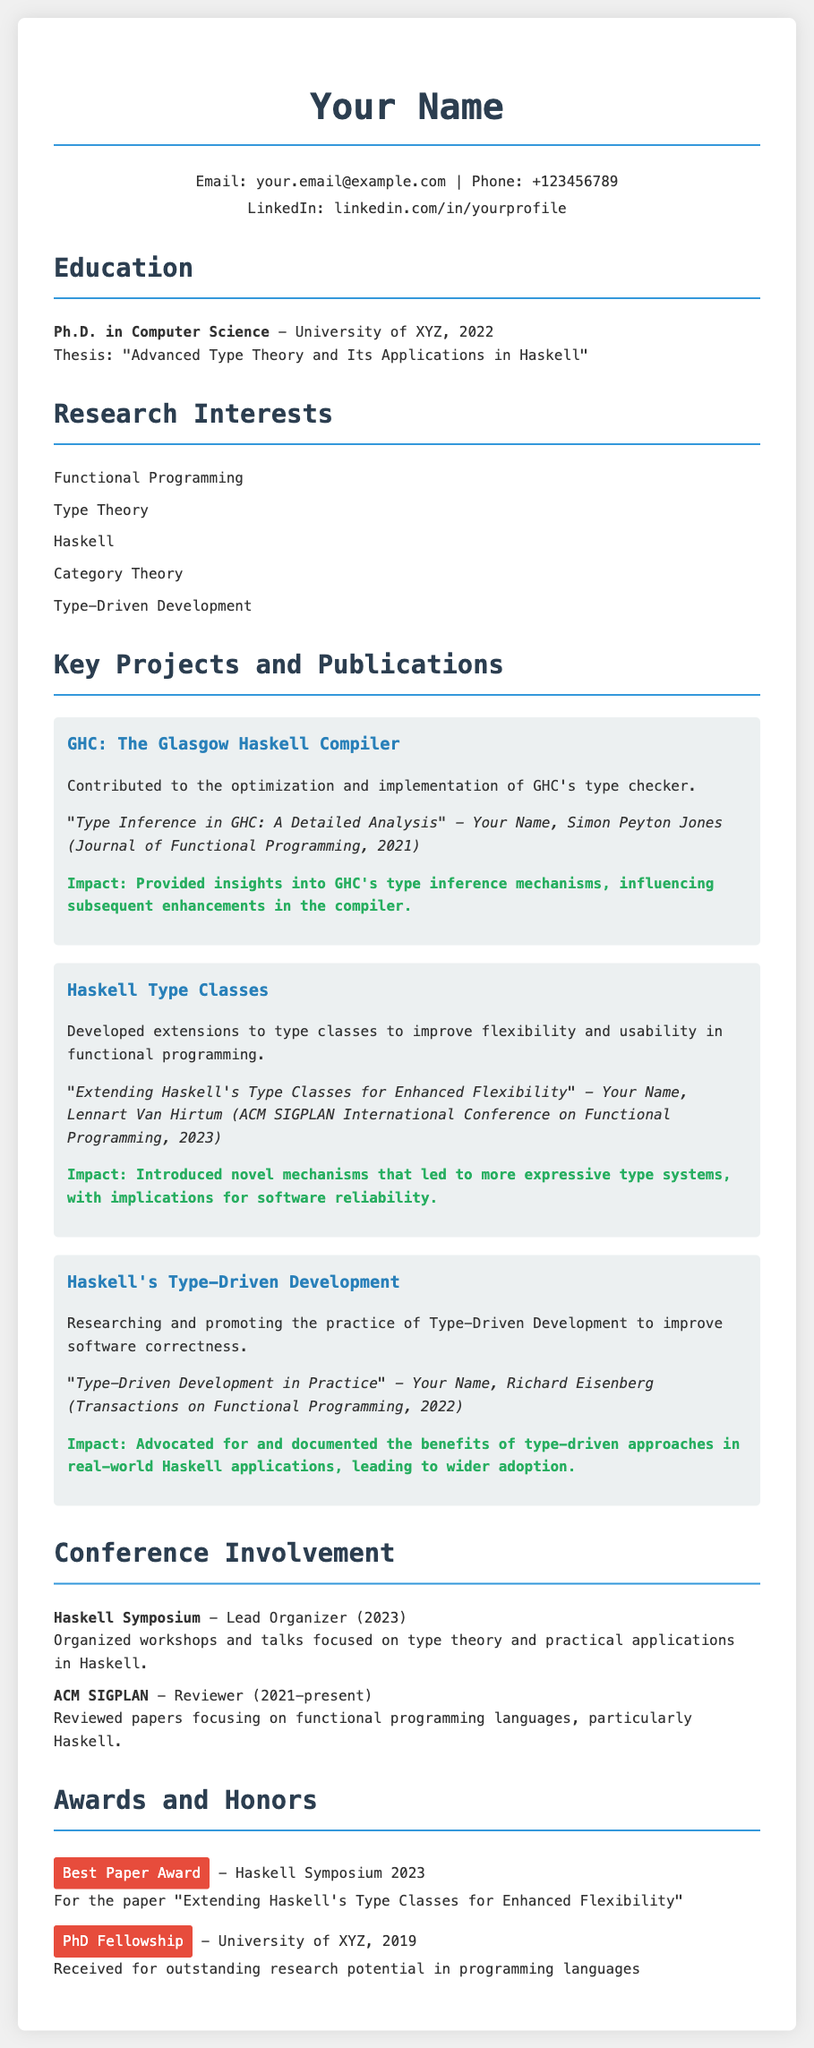What is the title of the Ph.D. thesis? The title of the thesis can be found under the Education section, which states "Advanced Type Theory and Its Applications in Haskell."
Answer: Advanced Type Theory and Its Applications in Haskell Who is a co-author of the paper on Type Inference in GHC? The document lists co-authors in the publication section, revealing Simon Peyton Jones as a co-author for that specific publication.
Answer: Simon Peyton Jones What year was the paper "Extending Haskell's Type Classes for Enhanced Flexibility" published? The publication date is included in the citation, which indicates it was published in 2023.
Answer: 2023 Which award was received for the best paper at the Haskell Symposium? The document specifies that the Best Paper Award was received for the paper "Extending Haskell's Type Classes for Enhanced Flexibility."
Answer: Best Paper Award What is the primary focus of the research on Haskell's Type-Driven Development? The statement in the project section indicates the focus is on improving software correctness through type-driven approaches.
Answer: Improving software correctness How many years has the individual been a reviewer for ACM SIGPLAN? The document states that the individual has been a reviewer from 2021 to present, indicating it has been 2 years.
Answer: 2 years What is the maximum width of the document's container in pixels? The style section shows that the maximum width of the container is set to 800 pixels.
Answer: 800 pixels What is the role of the individual in the Haskell Symposium? The document specifies that the individual served as the Lead Organizer for the Haskell Symposium in 2023.
Answer: Lead Organizer What is a key research interest listed in the document? The document enumerates research interests, and one of them is Functional Programming.
Answer: Functional Programming 